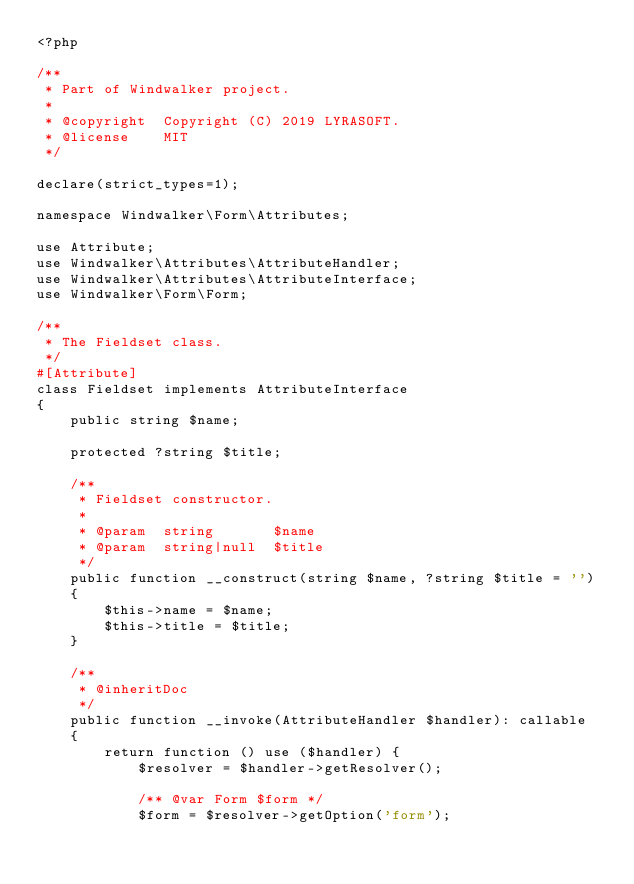<code> <loc_0><loc_0><loc_500><loc_500><_PHP_><?php

/**
 * Part of Windwalker project.
 *
 * @copyright  Copyright (C) 2019 LYRASOFT.
 * @license    MIT
 */

declare(strict_types=1);

namespace Windwalker\Form\Attributes;

use Attribute;
use Windwalker\Attributes\AttributeHandler;
use Windwalker\Attributes\AttributeInterface;
use Windwalker\Form\Form;

/**
 * The Fieldset class.
 */
#[Attribute]
class Fieldset implements AttributeInterface
{
    public string $name;

    protected ?string $title;

    /**
     * Fieldset constructor.
     *
     * @param  string       $name
     * @param  string|null  $title
     */
    public function __construct(string $name, ?string $title = '')
    {
        $this->name = $name;
        $this->title = $title;
    }

    /**
     * @inheritDoc
     */
    public function __invoke(AttributeHandler $handler): callable
    {
        return function () use ($handler) {
            $resolver = $handler->getResolver();

            /** @var Form $form */
            $form = $resolver->getOption('form');
</code> 